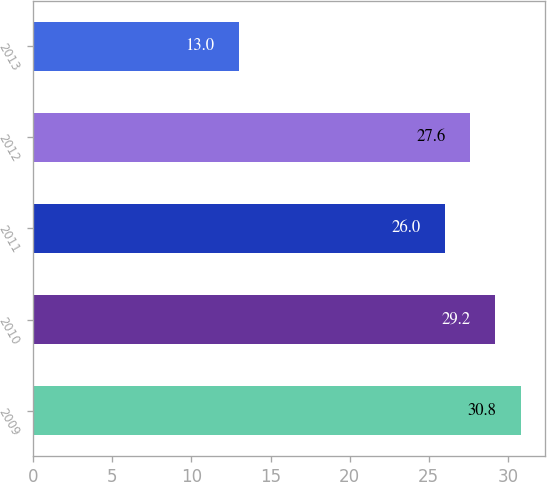<chart> <loc_0><loc_0><loc_500><loc_500><bar_chart><fcel>2009<fcel>2010<fcel>2011<fcel>2012<fcel>2013<nl><fcel>30.8<fcel>29.2<fcel>26<fcel>27.6<fcel>13<nl></chart> 